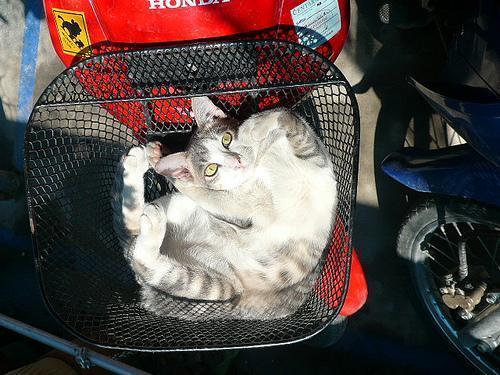How many motorcycles are in the picture?
Give a very brief answer. 2. How many elephants are facing the camera?
Give a very brief answer. 0. 